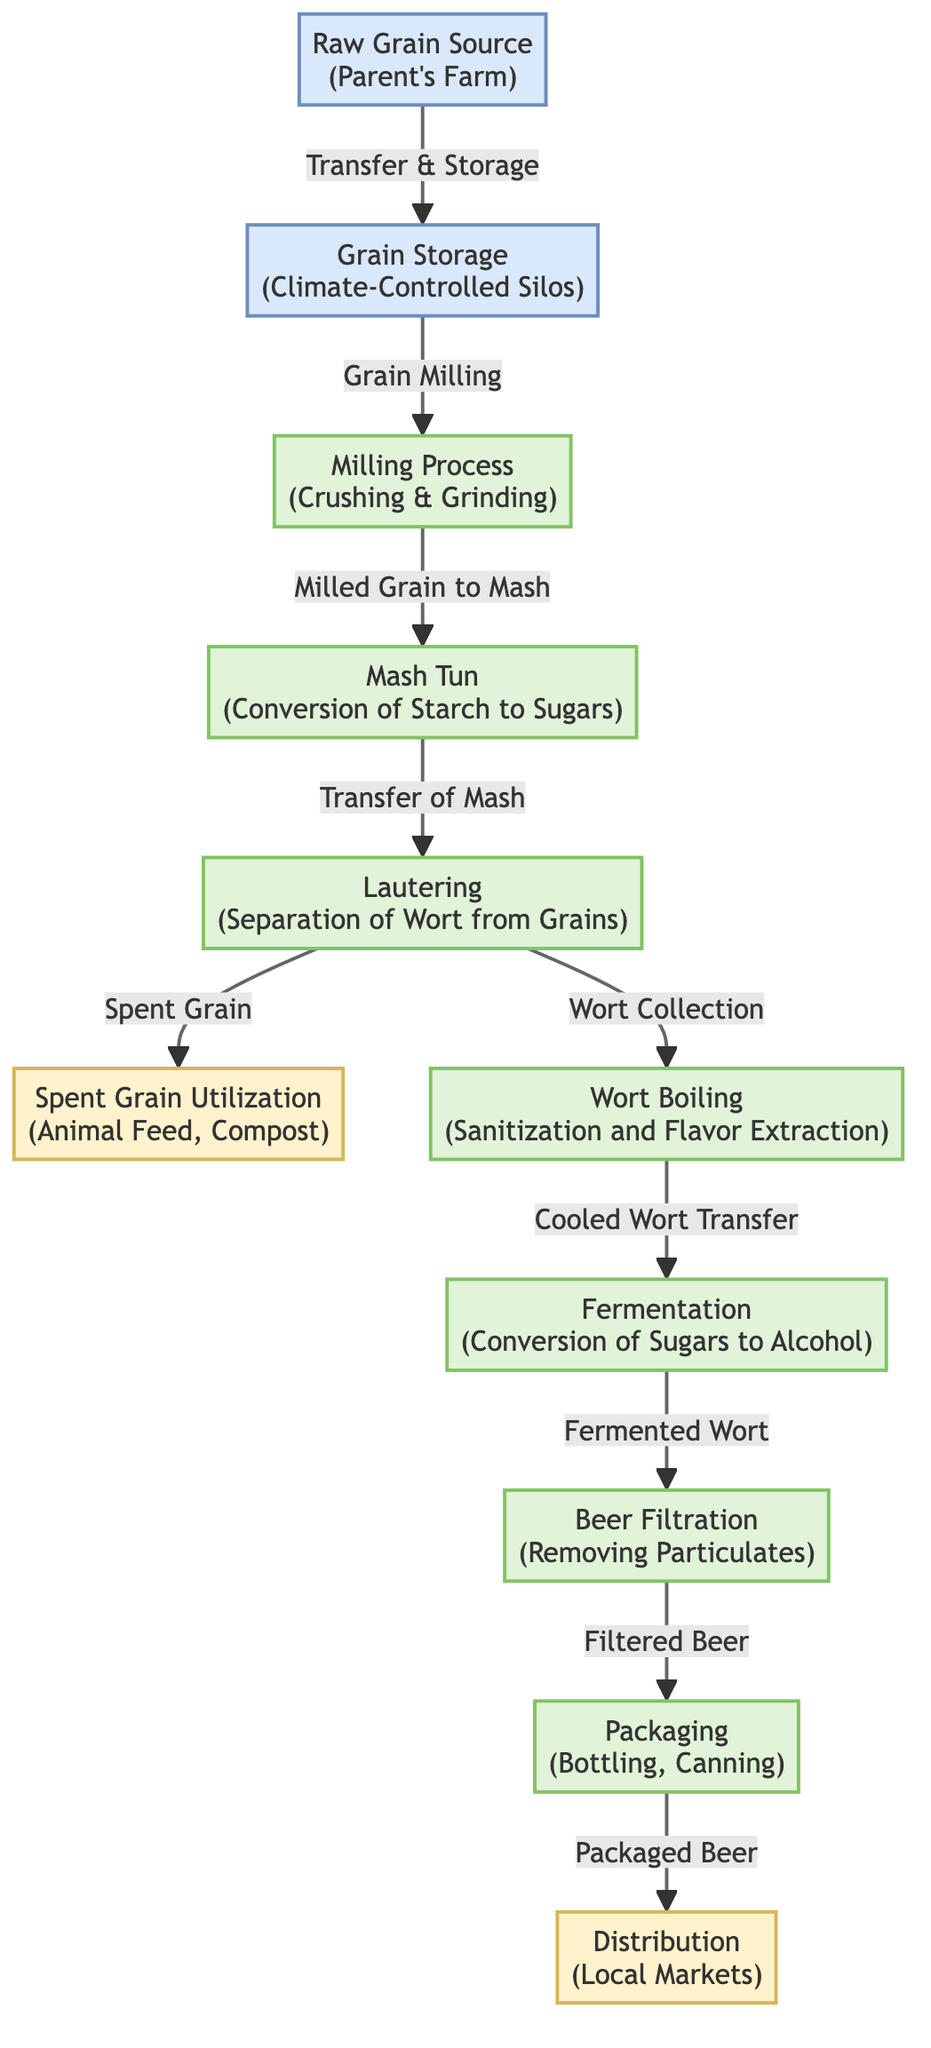What is the starting point of the process in the diagram? The starting point of the process is indicated by the first node in the diagram, which is labeled "Raw Grain Source (Parent's Farm)."
Answer: Raw Grain Source (Parent's Farm) How many main processes are represented in the diagram? The diagram lists several key processes; counting the nodes labeled as processes gives us eight main processes: Milling Process, Mash Tun, Lautering, Wort Boiling, Fermentation, Beer Filtration, and Packaging.
Answer: Eight What happens to spent grain according to the diagram? The diagram shows spent grain being directed toward two outputs: animal feed and compost, indicating how it is utilized after the lautering process.
Answer: Animal Feed, Compost What is the relationship between the grain storage and milling process? The arrow from the node "Grain Storage" to "Milling Process" indicates that grain is transferred from storage to the milling process for processing into milled grain.
Answer: Grain is transferred from storage to milling Which step follows the wort boiling process? After wort boiling, the next node in the flow indicates that the cooled wort is transferred to the fermentation step. By following the arrows in the diagram, we can see this clear sequential relationship.
Answer: Fermentation How is the spent grain utilized after the lautering step? The diagram shows that the spent grain is separated from the wort during the lautering process and is directed towards outputs such as animal feed and compost, demonstrating its use.
Answer: Animal Feed, Compost What is the final output in the distribution process? The final output from the process is conveyed through the packaging step, leading to the distribution of packaged beer, making this the last point in the production flow.
Answer: Packaged Beer In what environment is grain stored according to the diagram? The diagram specifies that the grain is stored in "Climate-Controlled Silos," emphasizing the controlled conditions that help maintain grain quality.
Answer: Climate-Controlled Silos 